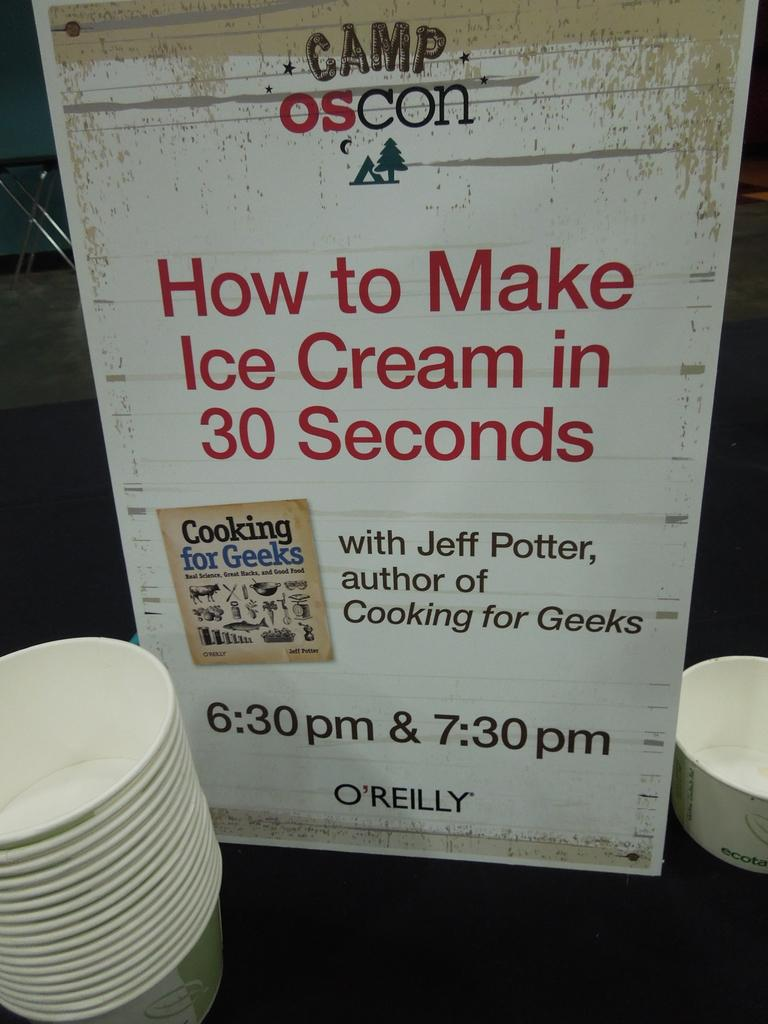What is featured in the image? There is a poster in the image. Where are the cups located in the image? There are cups on the bottom left of the image, and there is another cup on the right side of the image. What type of drum is being played by the stranger in the image? There is no stranger or drum present in the image. 